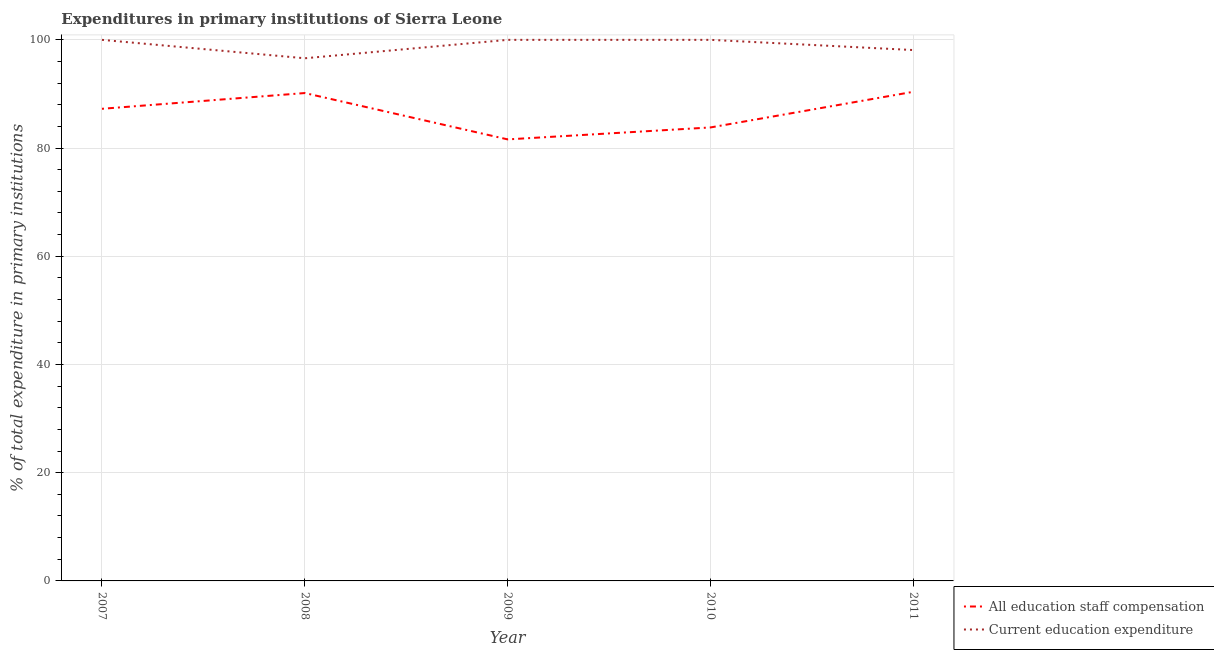What is the expenditure in education in 2011?
Provide a short and direct response. 98.12. Across all years, what is the maximum expenditure in staff compensation?
Give a very brief answer. 90.4. Across all years, what is the minimum expenditure in staff compensation?
Provide a succinct answer. 81.6. In which year was the expenditure in staff compensation minimum?
Offer a very short reply. 2009. What is the total expenditure in staff compensation in the graph?
Your answer should be very brief. 433.24. What is the difference between the expenditure in staff compensation in 2008 and that in 2010?
Offer a very short reply. 6.36. What is the difference between the expenditure in staff compensation in 2011 and the expenditure in education in 2009?
Your answer should be compact. -9.6. What is the average expenditure in staff compensation per year?
Keep it short and to the point. 86.65. In the year 2009, what is the difference between the expenditure in staff compensation and expenditure in education?
Offer a terse response. -18.4. What is the ratio of the expenditure in staff compensation in 2008 to that in 2010?
Provide a succinct answer. 1.08. Is the expenditure in education in 2007 less than that in 2009?
Your answer should be compact. No. What is the difference between the highest and the second highest expenditure in staff compensation?
Ensure brevity in your answer.  0.23. What is the difference between the highest and the lowest expenditure in staff compensation?
Ensure brevity in your answer.  8.8. In how many years, is the expenditure in staff compensation greater than the average expenditure in staff compensation taken over all years?
Keep it short and to the point. 3. Is the sum of the expenditure in staff compensation in 2009 and 2010 greater than the maximum expenditure in education across all years?
Provide a short and direct response. Yes. Does the expenditure in staff compensation monotonically increase over the years?
Offer a very short reply. No. Is the expenditure in staff compensation strictly greater than the expenditure in education over the years?
Give a very brief answer. No. Is the expenditure in education strictly less than the expenditure in staff compensation over the years?
Offer a terse response. No. How many lines are there?
Keep it short and to the point. 2. What is the difference between two consecutive major ticks on the Y-axis?
Make the answer very short. 20. Does the graph contain any zero values?
Keep it short and to the point. No. How are the legend labels stacked?
Keep it short and to the point. Vertical. What is the title of the graph?
Give a very brief answer. Expenditures in primary institutions of Sierra Leone. Does "Tetanus" appear as one of the legend labels in the graph?
Your answer should be compact. No. What is the label or title of the X-axis?
Ensure brevity in your answer.  Year. What is the label or title of the Y-axis?
Give a very brief answer. % of total expenditure in primary institutions. What is the % of total expenditure in primary institutions in All education staff compensation in 2007?
Keep it short and to the point. 87.26. What is the % of total expenditure in primary institutions in Current education expenditure in 2007?
Provide a succinct answer. 100. What is the % of total expenditure in primary institutions in All education staff compensation in 2008?
Your answer should be compact. 90.17. What is the % of total expenditure in primary institutions in Current education expenditure in 2008?
Your answer should be very brief. 96.6. What is the % of total expenditure in primary institutions of All education staff compensation in 2009?
Provide a short and direct response. 81.6. What is the % of total expenditure in primary institutions in All education staff compensation in 2010?
Offer a terse response. 83.81. What is the % of total expenditure in primary institutions of Current education expenditure in 2010?
Keep it short and to the point. 100. What is the % of total expenditure in primary institutions in All education staff compensation in 2011?
Give a very brief answer. 90.4. What is the % of total expenditure in primary institutions in Current education expenditure in 2011?
Your answer should be very brief. 98.12. Across all years, what is the maximum % of total expenditure in primary institutions of All education staff compensation?
Your response must be concise. 90.4. Across all years, what is the maximum % of total expenditure in primary institutions in Current education expenditure?
Make the answer very short. 100. Across all years, what is the minimum % of total expenditure in primary institutions of All education staff compensation?
Your response must be concise. 81.6. Across all years, what is the minimum % of total expenditure in primary institutions in Current education expenditure?
Offer a terse response. 96.6. What is the total % of total expenditure in primary institutions of All education staff compensation in the graph?
Your response must be concise. 433.24. What is the total % of total expenditure in primary institutions of Current education expenditure in the graph?
Offer a terse response. 494.71. What is the difference between the % of total expenditure in primary institutions of All education staff compensation in 2007 and that in 2008?
Provide a succinct answer. -2.91. What is the difference between the % of total expenditure in primary institutions in Current education expenditure in 2007 and that in 2008?
Provide a short and direct response. 3.4. What is the difference between the % of total expenditure in primary institutions in All education staff compensation in 2007 and that in 2009?
Your response must be concise. 5.66. What is the difference between the % of total expenditure in primary institutions in Current education expenditure in 2007 and that in 2009?
Offer a very short reply. 0. What is the difference between the % of total expenditure in primary institutions in All education staff compensation in 2007 and that in 2010?
Your response must be concise. 3.45. What is the difference between the % of total expenditure in primary institutions of Current education expenditure in 2007 and that in 2010?
Offer a terse response. 0. What is the difference between the % of total expenditure in primary institutions in All education staff compensation in 2007 and that in 2011?
Your answer should be compact. -3.14. What is the difference between the % of total expenditure in primary institutions of Current education expenditure in 2007 and that in 2011?
Your answer should be compact. 1.88. What is the difference between the % of total expenditure in primary institutions in All education staff compensation in 2008 and that in 2009?
Give a very brief answer. 8.57. What is the difference between the % of total expenditure in primary institutions of Current education expenditure in 2008 and that in 2009?
Offer a terse response. -3.4. What is the difference between the % of total expenditure in primary institutions of All education staff compensation in 2008 and that in 2010?
Offer a terse response. 6.36. What is the difference between the % of total expenditure in primary institutions in Current education expenditure in 2008 and that in 2010?
Your answer should be very brief. -3.4. What is the difference between the % of total expenditure in primary institutions in All education staff compensation in 2008 and that in 2011?
Offer a terse response. -0.23. What is the difference between the % of total expenditure in primary institutions in Current education expenditure in 2008 and that in 2011?
Offer a terse response. -1.52. What is the difference between the % of total expenditure in primary institutions of All education staff compensation in 2009 and that in 2010?
Your answer should be compact. -2.21. What is the difference between the % of total expenditure in primary institutions of All education staff compensation in 2009 and that in 2011?
Give a very brief answer. -8.8. What is the difference between the % of total expenditure in primary institutions of Current education expenditure in 2009 and that in 2011?
Offer a terse response. 1.88. What is the difference between the % of total expenditure in primary institutions in All education staff compensation in 2010 and that in 2011?
Make the answer very short. -6.59. What is the difference between the % of total expenditure in primary institutions in Current education expenditure in 2010 and that in 2011?
Keep it short and to the point. 1.88. What is the difference between the % of total expenditure in primary institutions of All education staff compensation in 2007 and the % of total expenditure in primary institutions of Current education expenditure in 2008?
Provide a succinct answer. -9.34. What is the difference between the % of total expenditure in primary institutions of All education staff compensation in 2007 and the % of total expenditure in primary institutions of Current education expenditure in 2009?
Make the answer very short. -12.74. What is the difference between the % of total expenditure in primary institutions of All education staff compensation in 2007 and the % of total expenditure in primary institutions of Current education expenditure in 2010?
Provide a succinct answer. -12.74. What is the difference between the % of total expenditure in primary institutions of All education staff compensation in 2007 and the % of total expenditure in primary institutions of Current education expenditure in 2011?
Give a very brief answer. -10.86. What is the difference between the % of total expenditure in primary institutions in All education staff compensation in 2008 and the % of total expenditure in primary institutions in Current education expenditure in 2009?
Ensure brevity in your answer.  -9.83. What is the difference between the % of total expenditure in primary institutions in All education staff compensation in 2008 and the % of total expenditure in primary institutions in Current education expenditure in 2010?
Keep it short and to the point. -9.83. What is the difference between the % of total expenditure in primary institutions in All education staff compensation in 2008 and the % of total expenditure in primary institutions in Current education expenditure in 2011?
Make the answer very short. -7.95. What is the difference between the % of total expenditure in primary institutions in All education staff compensation in 2009 and the % of total expenditure in primary institutions in Current education expenditure in 2010?
Give a very brief answer. -18.4. What is the difference between the % of total expenditure in primary institutions in All education staff compensation in 2009 and the % of total expenditure in primary institutions in Current education expenditure in 2011?
Your answer should be compact. -16.51. What is the difference between the % of total expenditure in primary institutions in All education staff compensation in 2010 and the % of total expenditure in primary institutions in Current education expenditure in 2011?
Keep it short and to the point. -14.3. What is the average % of total expenditure in primary institutions of All education staff compensation per year?
Provide a succinct answer. 86.65. What is the average % of total expenditure in primary institutions of Current education expenditure per year?
Keep it short and to the point. 98.94. In the year 2007, what is the difference between the % of total expenditure in primary institutions of All education staff compensation and % of total expenditure in primary institutions of Current education expenditure?
Provide a short and direct response. -12.74. In the year 2008, what is the difference between the % of total expenditure in primary institutions in All education staff compensation and % of total expenditure in primary institutions in Current education expenditure?
Provide a succinct answer. -6.43. In the year 2009, what is the difference between the % of total expenditure in primary institutions in All education staff compensation and % of total expenditure in primary institutions in Current education expenditure?
Your answer should be very brief. -18.4. In the year 2010, what is the difference between the % of total expenditure in primary institutions of All education staff compensation and % of total expenditure in primary institutions of Current education expenditure?
Provide a short and direct response. -16.19. In the year 2011, what is the difference between the % of total expenditure in primary institutions of All education staff compensation and % of total expenditure in primary institutions of Current education expenditure?
Your answer should be compact. -7.71. What is the ratio of the % of total expenditure in primary institutions of Current education expenditure in 2007 to that in 2008?
Provide a short and direct response. 1.04. What is the ratio of the % of total expenditure in primary institutions of All education staff compensation in 2007 to that in 2009?
Offer a terse response. 1.07. What is the ratio of the % of total expenditure in primary institutions of All education staff compensation in 2007 to that in 2010?
Provide a succinct answer. 1.04. What is the ratio of the % of total expenditure in primary institutions of All education staff compensation in 2007 to that in 2011?
Provide a succinct answer. 0.97. What is the ratio of the % of total expenditure in primary institutions in Current education expenditure in 2007 to that in 2011?
Give a very brief answer. 1.02. What is the ratio of the % of total expenditure in primary institutions of All education staff compensation in 2008 to that in 2009?
Your answer should be very brief. 1.1. What is the ratio of the % of total expenditure in primary institutions of Current education expenditure in 2008 to that in 2009?
Provide a succinct answer. 0.97. What is the ratio of the % of total expenditure in primary institutions of All education staff compensation in 2008 to that in 2010?
Offer a terse response. 1.08. What is the ratio of the % of total expenditure in primary institutions of All education staff compensation in 2008 to that in 2011?
Provide a short and direct response. 1. What is the ratio of the % of total expenditure in primary institutions of Current education expenditure in 2008 to that in 2011?
Provide a succinct answer. 0.98. What is the ratio of the % of total expenditure in primary institutions of All education staff compensation in 2009 to that in 2010?
Give a very brief answer. 0.97. What is the ratio of the % of total expenditure in primary institutions of Current education expenditure in 2009 to that in 2010?
Give a very brief answer. 1. What is the ratio of the % of total expenditure in primary institutions of All education staff compensation in 2009 to that in 2011?
Keep it short and to the point. 0.9. What is the ratio of the % of total expenditure in primary institutions in Current education expenditure in 2009 to that in 2011?
Make the answer very short. 1.02. What is the ratio of the % of total expenditure in primary institutions in All education staff compensation in 2010 to that in 2011?
Keep it short and to the point. 0.93. What is the ratio of the % of total expenditure in primary institutions of Current education expenditure in 2010 to that in 2011?
Offer a terse response. 1.02. What is the difference between the highest and the second highest % of total expenditure in primary institutions in All education staff compensation?
Your response must be concise. 0.23. What is the difference between the highest and the second highest % of total expenditure in primary institutions in Current education expenditure?
Your answer should be compact. 0. What is the difference between the highest and the lowest % of total expenditure in primary institutions in All education staff compensation?
Offer a very short reply. 8.8. What is the difference between the highest and the lowest % of total expenditure in primary institutions in Current education expenditure?
Provide a succinct answer. 3.4. 